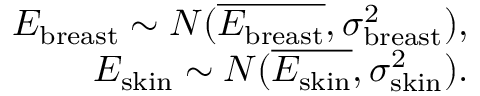Convert formula to latex. <formula><loc_0><loc_0><loc_500><loc_500>\begin{array} { r } { E _ { b r e a s t } \sim N ( \overline { { E _ { b r e a s t } } } , \sigma _ { b r e a s t } ^ { 2 } ) , } \\ { E _ { s k i n } \sim N ( \overline { { E _ { s k i n } } } , \sigma _ { s k i n } ^ { 2 } ) . } \end{array}</formula> 